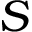<formula> <loc_0><loc_0><loc_500><loc_500>S</formula> 